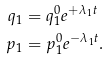<formula> <loc_0><loc_0><loc_500><loc_500>q _ { 1 } & = q _ { 1 } ^ { 0 } e ^ { + \lambda _ { 1 } t } \\ p _ { 1 } & = p _ { 1 } ^ { 0 } e ^ { - \lambda _ { 1 } t } .</formula> 